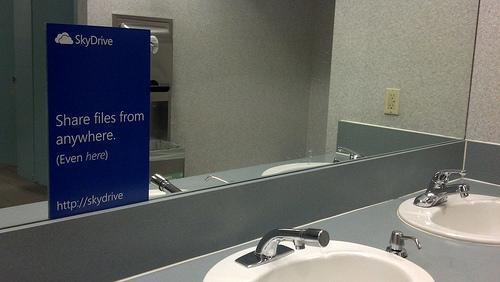How many plug ins are available for use?
Give a very brief answer. 2. 